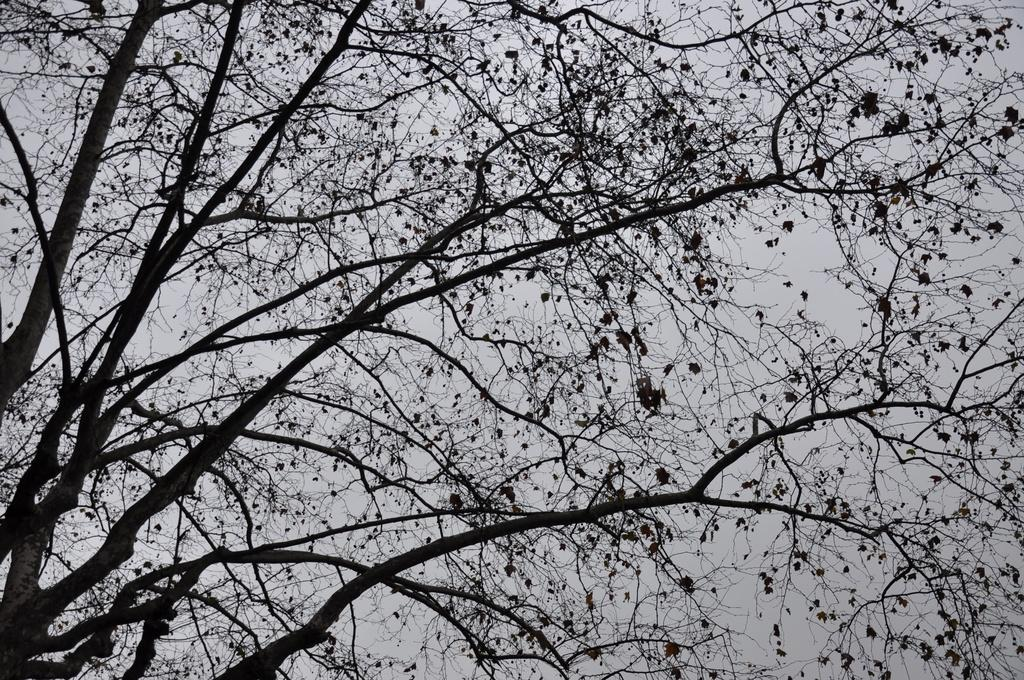What is the main object in the image? There is a tree in the image. Can you describe the tree's appearance? The tree has many branches and dry leaves. Where is the volleyball located in the image? There is no volleyball present in the image. What type of cub can be seen playing with the tree in the image? There is no cub present in the image, and the tree is not depicted as an object for play. 